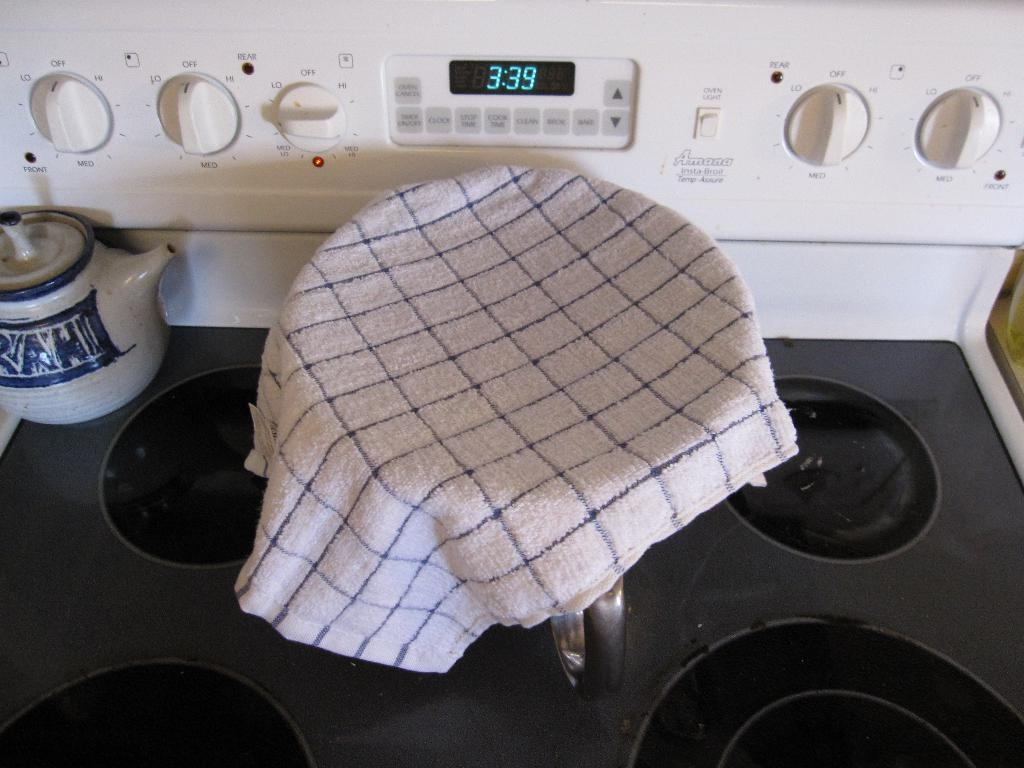<image>
Provide a brief description of the given image. A stove clock displays a time of 3:39. 